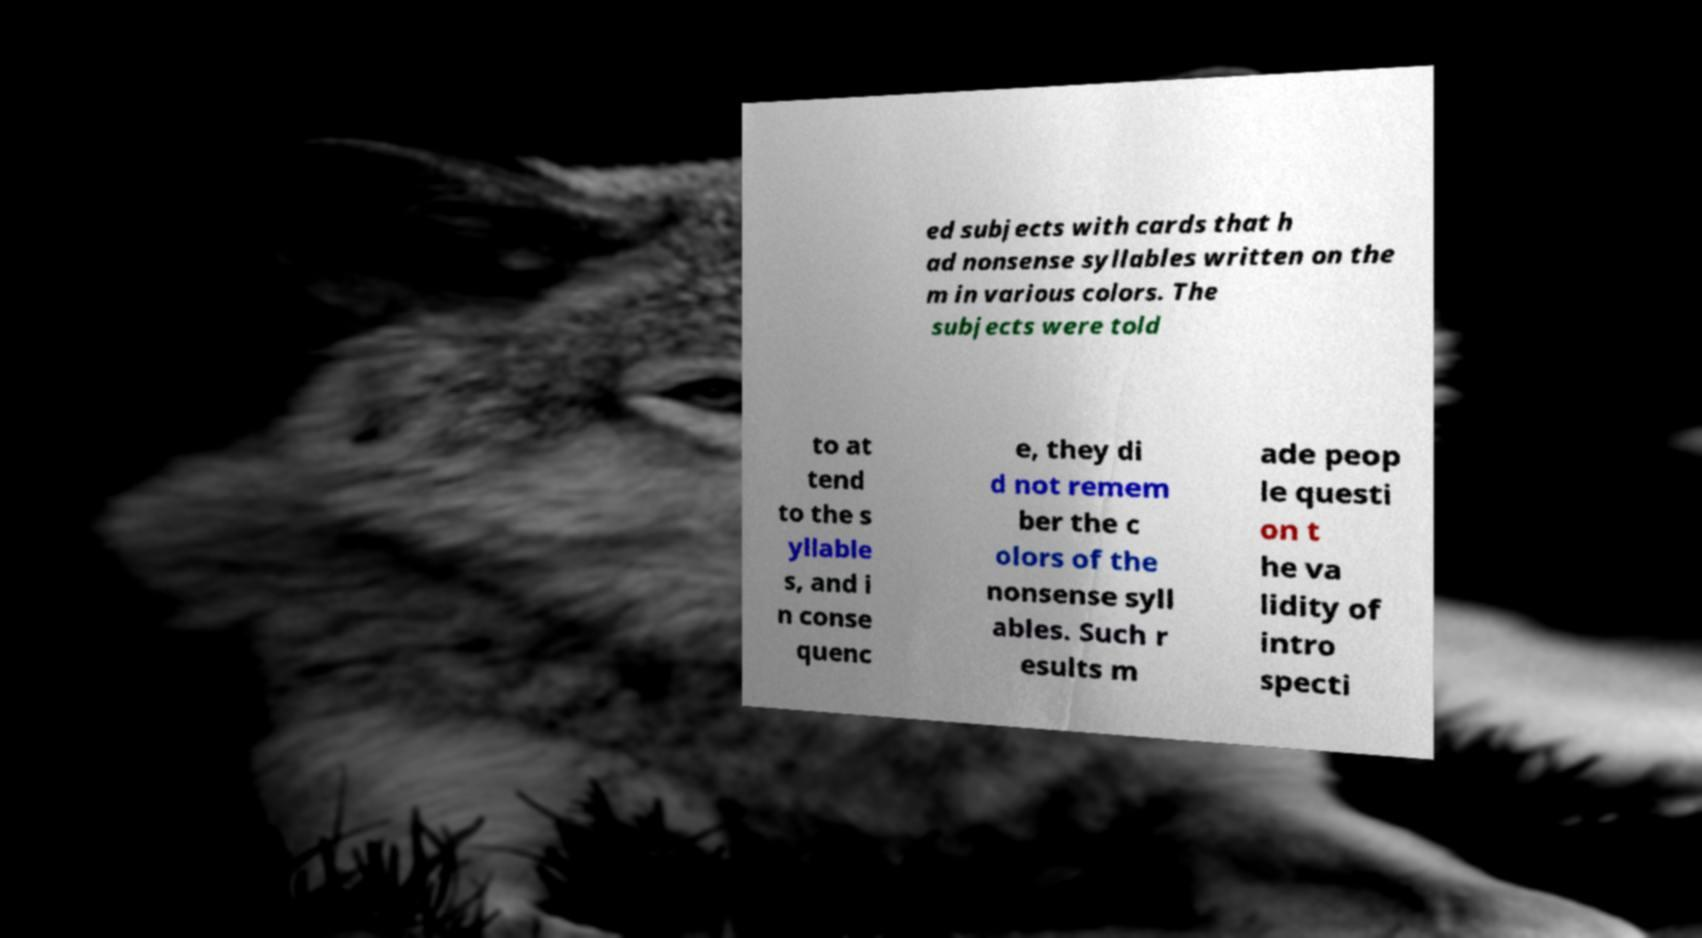There's text embedded in this image that I need extracted. Can you transcribe it verbatim? ed subjects with cards that h ad nonsense syllables written on the m in various colors. The subjects were told to at tend to the s yllable s, and i n conse quenc e, they di d not remem ber the c olors of the nonsense syll ables. Such r esults m ade peop le questi on t he va lidity of intro specti 